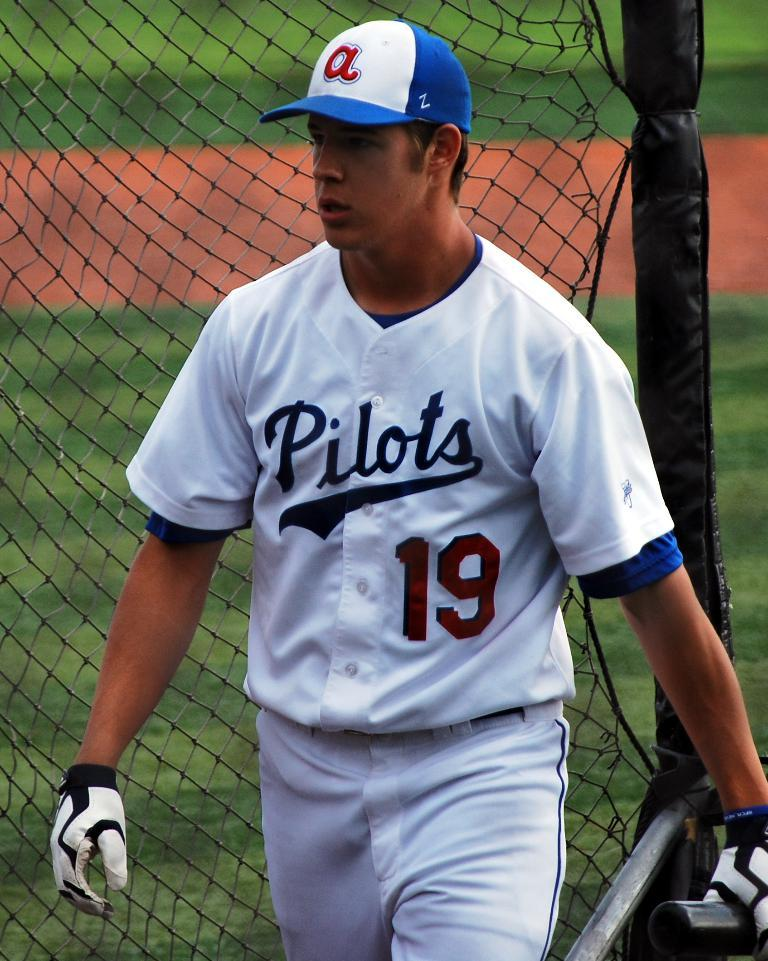Provide a one-sentence caption for the provided image. A baseball player stands on the field wearing a white uniform with Pilots across the front in blue and the number 19 in red. 